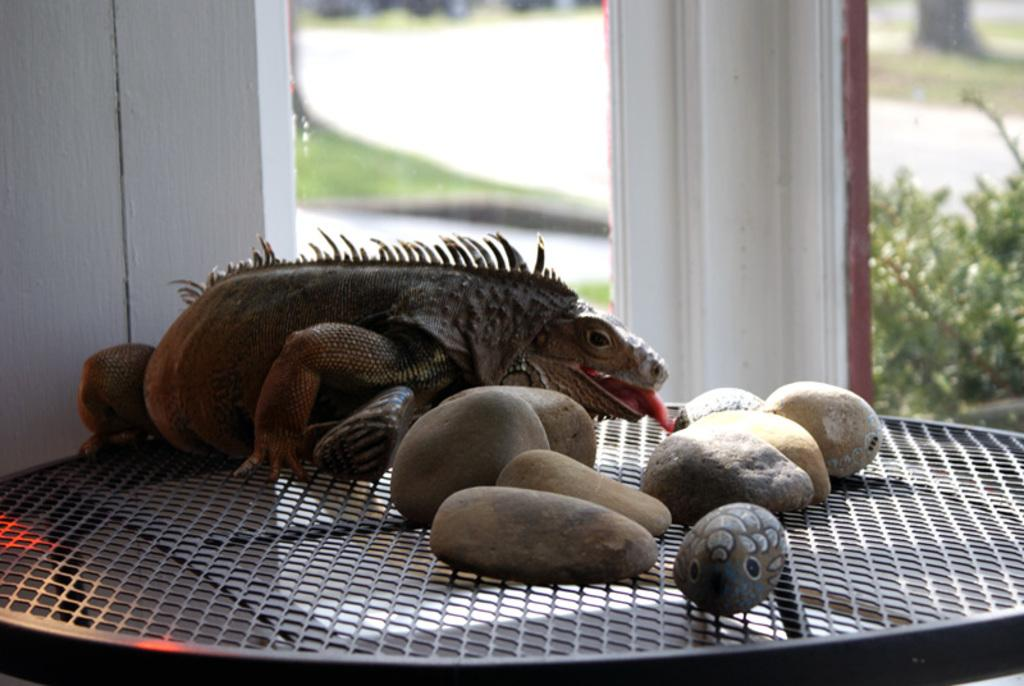What type of animal is in the image? There is a frog in the image. What is placed on a mesh in the image? There are stones on a mesh in the image. What can be seen in the background of the image? There are pillars and plants in the background of the image. What type of dirt can be seen on the frog's skin in the image? There is no dirt visible on the frog's skin in the image. What payment method is being used for the stones on the mesh in the image? There is no payment method present in the image, as it only shows stones on a mesh. 